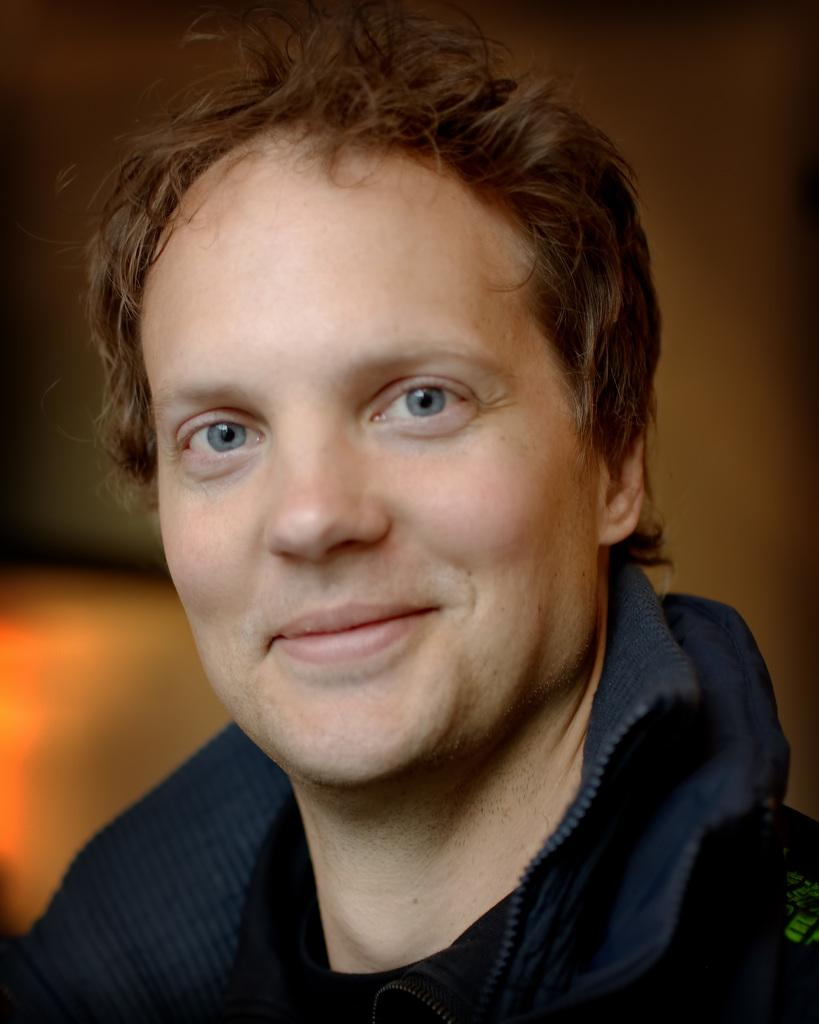What is the main subject in the image? There is a person in the image. Can you tell me how deep the river is under the person's feet in the image? There is no river present in the image, and therefore no depth to measure. 